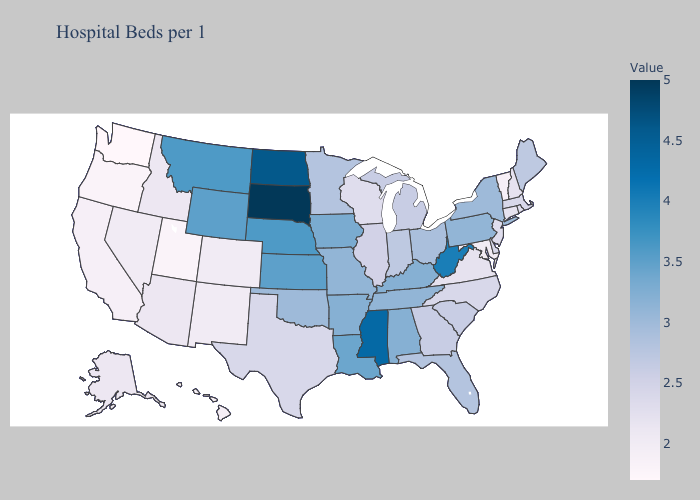Does South Dakota have the highest value in the USA?
Keep it brief. Yes. Among the states that border Michigan , does Indiana have the highest value?
Give a very brief answer. No. Does Vermont have the lowest value in the Northeast?
Short answer required. Yes. Which states hav the highest value in the South?
Quick response, please. Mississippi. Does the map have missing data?
Give a very brief answer. No. Which states hav the highest value in the West?
Write a very short answer. Montana. Does Nebraska have the highest value in the USA?
Answer briefly. No. Which states have the lowest value in the USA?
Answer briefly. Washington. 